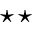<formula> <loc_0><loc_0><loc_500><loc_500>^ { * } ^ { * }</formula> 